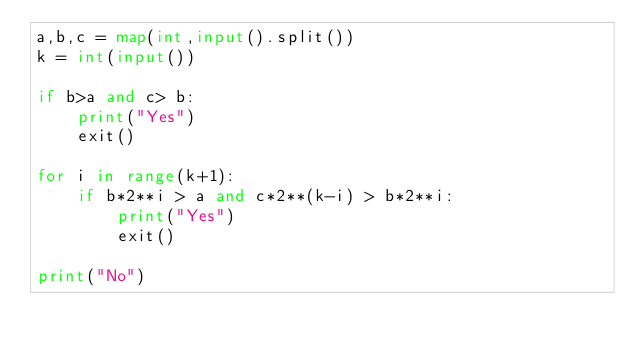Convert code to text. <code><loc_0><loc_0><loc_500><loc_500><_Python_>a,b,c = map(int,input().split())
k = int(input())

if b>a and c> b:
    print("Yes")
    exit()

for i in range(k+1):
    if b*2**i > a and c*2**(k-i) > b*2**i:
        print("Yes")
        exit()

print("No")
</code> 